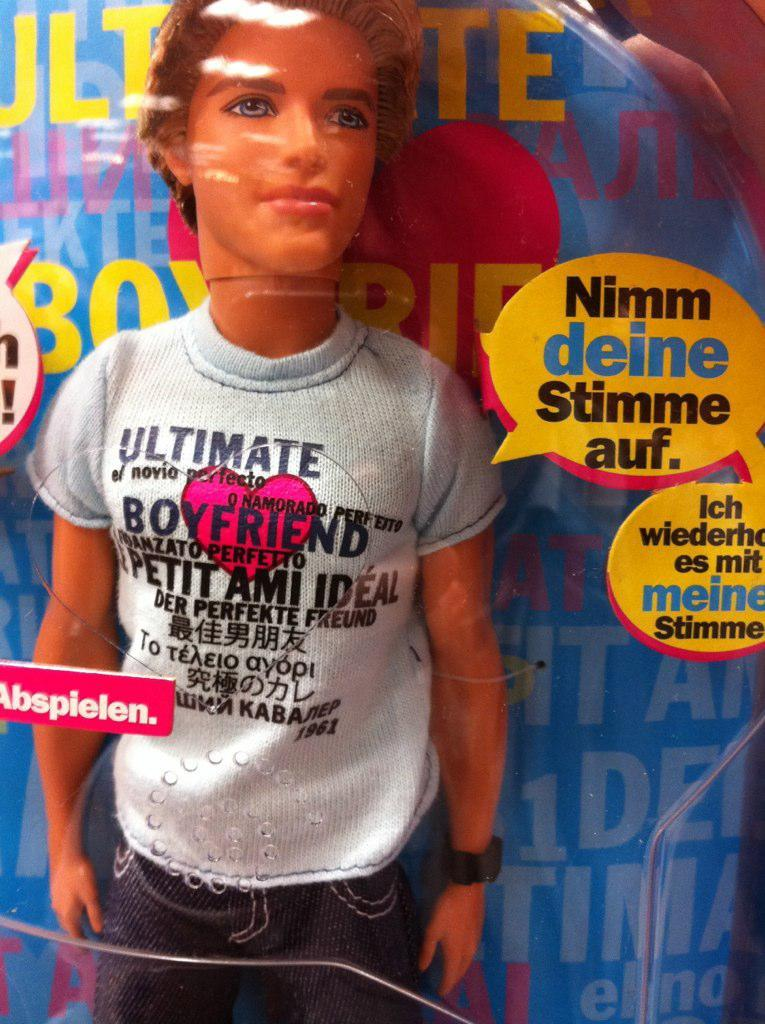What is present in the image? There is a doll in the image. What can be observed on the doll? There are writings on the doll. What type of development is taking place on the yak in the image? There is no yak present in the image, so it is not possible to answer that question. 